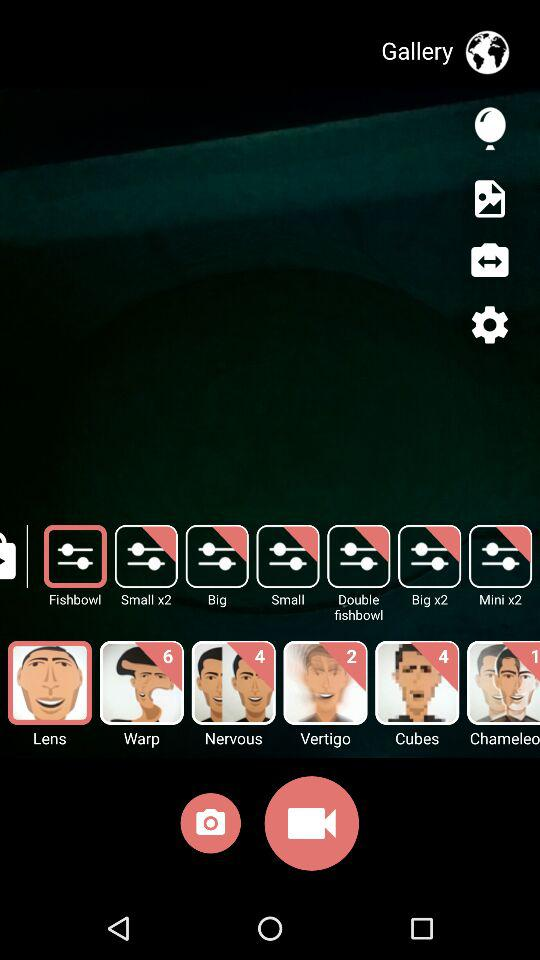Write the names of a few options available on the screen?
When the provided information is insufficient, respond with <no answer>. <no answer> 